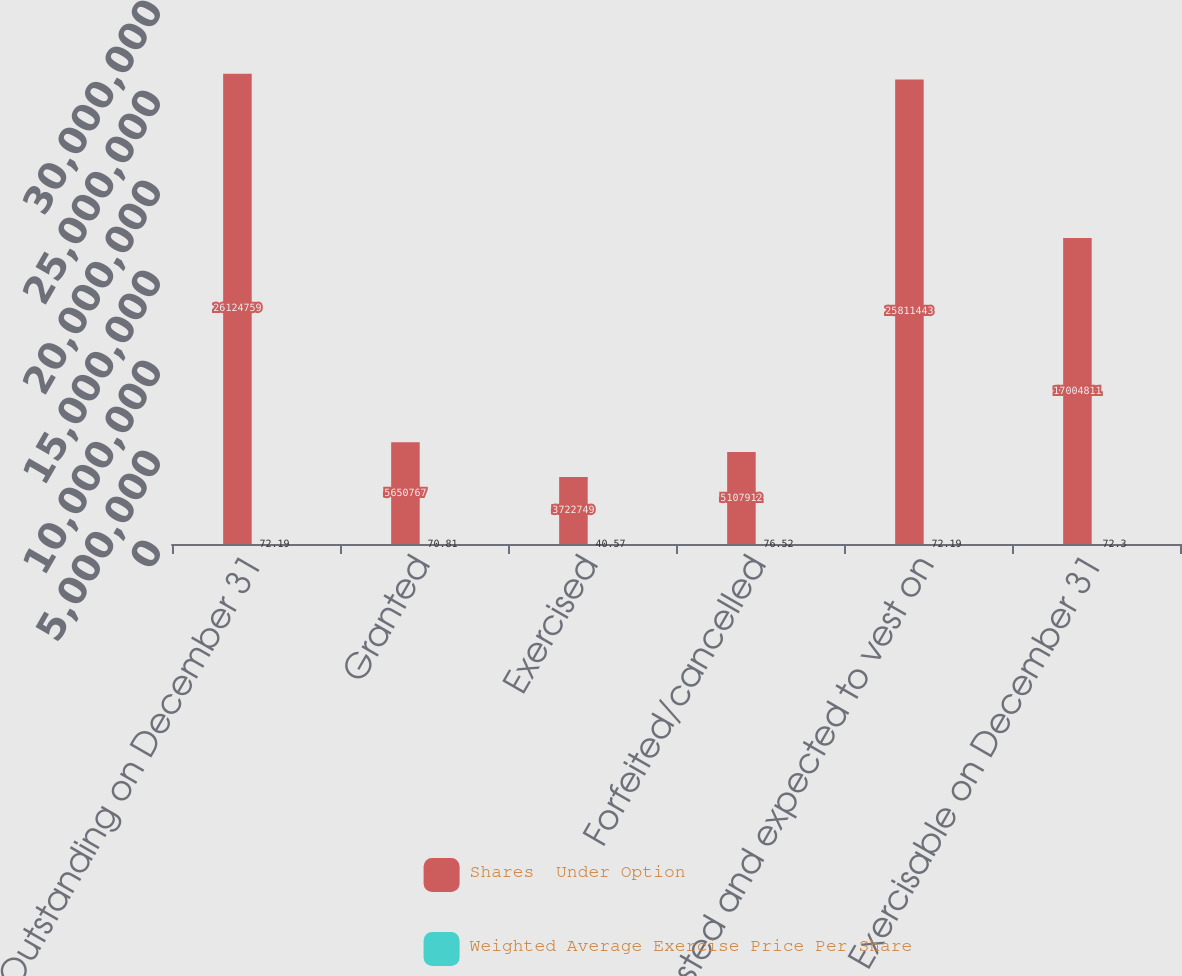<chart> <loc_0><loc_0><loc_500><loc_500><stacked_bar_chart><ecel><fcel>Outstanding on December 31<fcel>Granted<fcel>Exercised<fcel>Forfeited/cancelled<fcel>Vested and expected to vest on<fcel>Exercisable on December 31<nl><fcel>Shares  Under Option<fcel>2.61248e+07<fcel>5.65077e+06<fcel>3.72275e+06<fcel>5.10791e+06<fcel>2.58114e+07<fcel>1.70048e+07<nl><fcel>Weighted Average Exercise Price Per Share<fcel>72.19<fcel>70.81<fcel>40.57<fcel>76.52<fcel>72.19<fcel>72.3<nl></chart> 